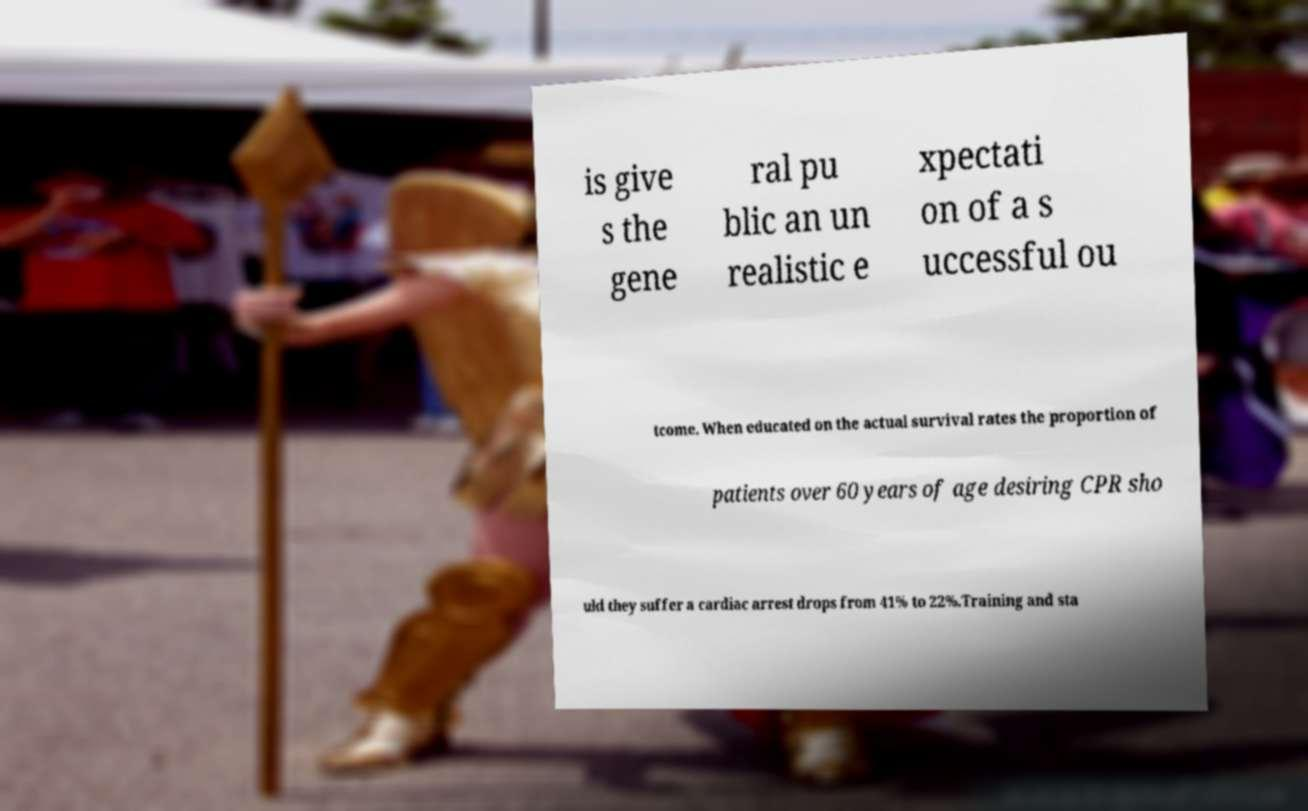Could you extract and type out the text from this image? is give s the gene ral pu blic an un realistic e xpectati on of a s uccessful ou tcome. When educated on the actual survival rates the proportion of patients over 60 years of age desiring CPR sho uld they suffer a cardiac arrest drops from 41% to 22%.Training and sta 